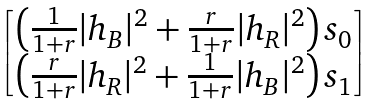<formula> <loc_0><loc_0><loc_500><loc_500>\begin{bmatrix} \left ( \frac { 1 } { 1 + r } | h _ { B } | ^ { 2 } + \frac { r } { 1 + r } | h _ { R } | ^ { 2 } \right ) s _ { 0 } \\ \left ( \frac { r } { 1 + r } | h _ { R } | ^ { 2 } + \frac { 1 } { 1 + r } | h _ { B } | ^ { 2 } \right ) s _ { 1 } \end{bmatrix}</formula> 